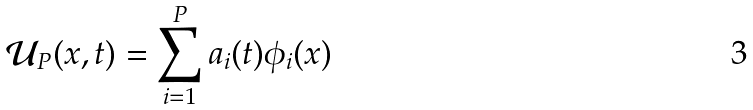<formula> <loc_0><loc_0><loc_500><loc_500>\mathcal { U } _ { P } ( x , t ) = \sum _ { i = 1 } ^ { P } a _ { i } ( t ) \phi _ { i } ( x )</formula> 